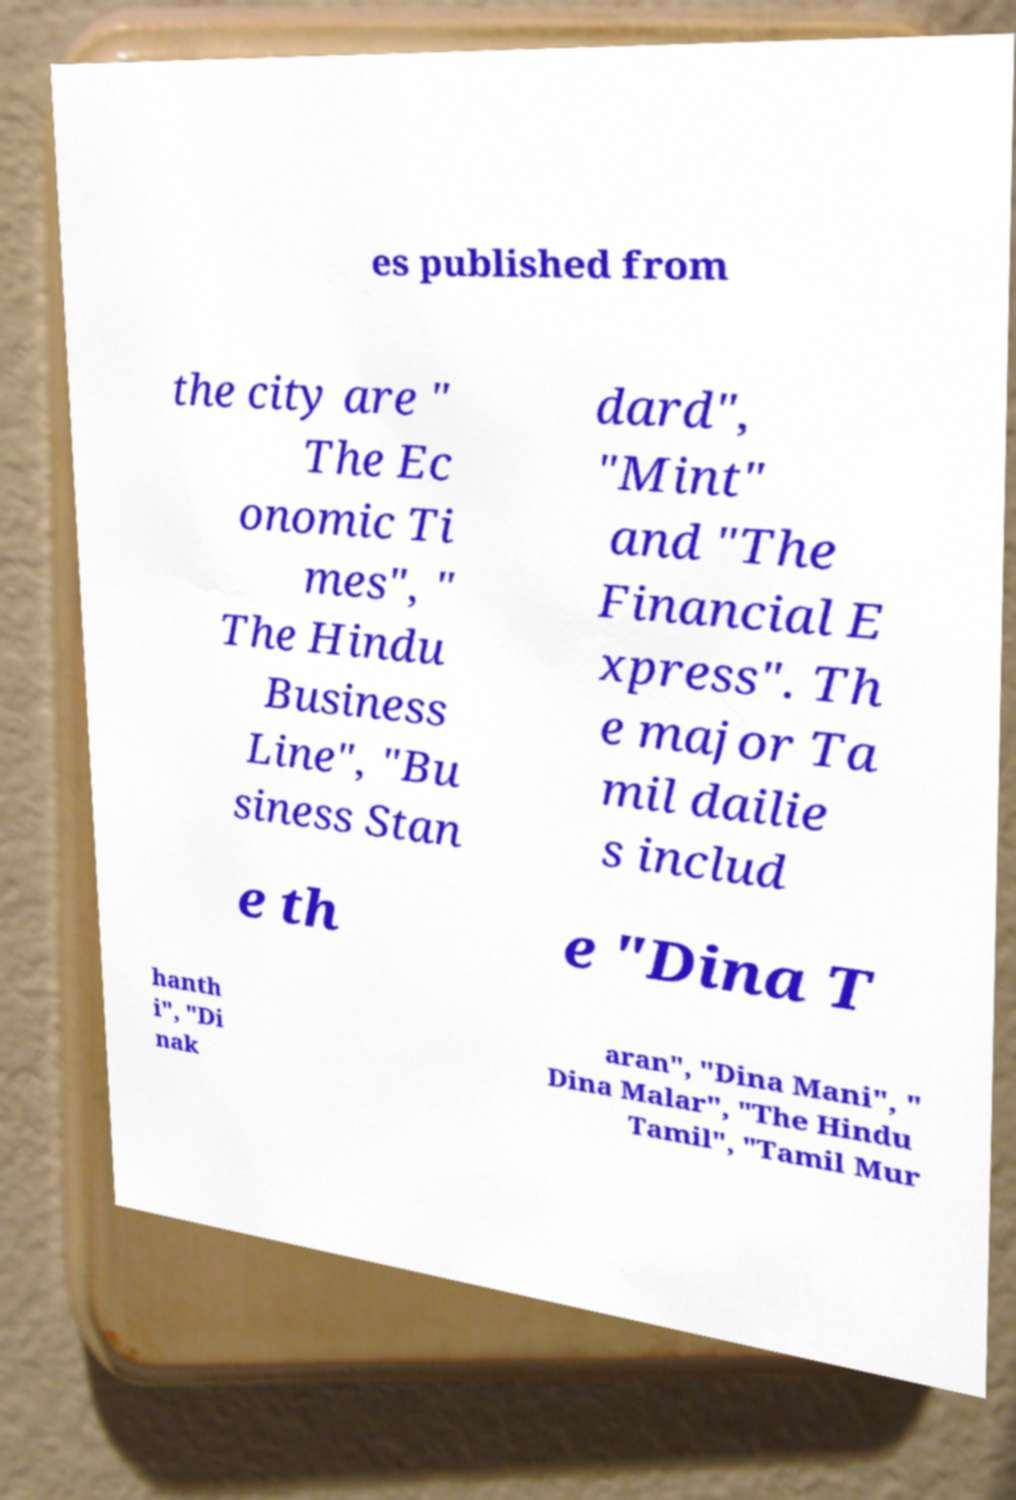I need the written content from this picture converted into text. Can you do that? es published from the city are " The Ec onomic Ti mes", " The Hindu Business Line", "Bu siness Stan dard", "Mint" and "The Financial E xpress". Th e major Ta mil dailie s includ e th e "Dina T hanth i", "Di nak aran", "Dina Mani", " Dina Malar", "The Hindu Tamil", "Tamil Mur 